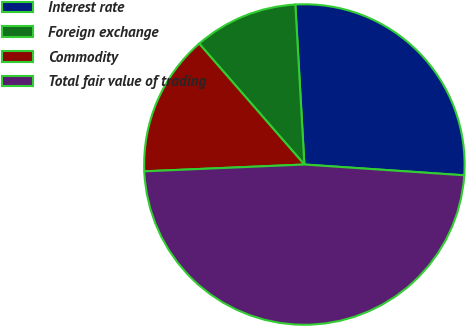Convert chart. <chart><loc_0><loc_0><loc_500><loc_500><pie_chart><fcel>Interest rate<fcel>Foreign exchange<fcel>Commodity<fcel>Total fair value of trading<nl><fcel>26.97%<fcel>10.5%<fcel>14.28%<fcel>48.25%<nl></chart> 